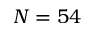<formula> <loc_0><loc_0><loc_500><loc_500>N = 5 4</formula> 